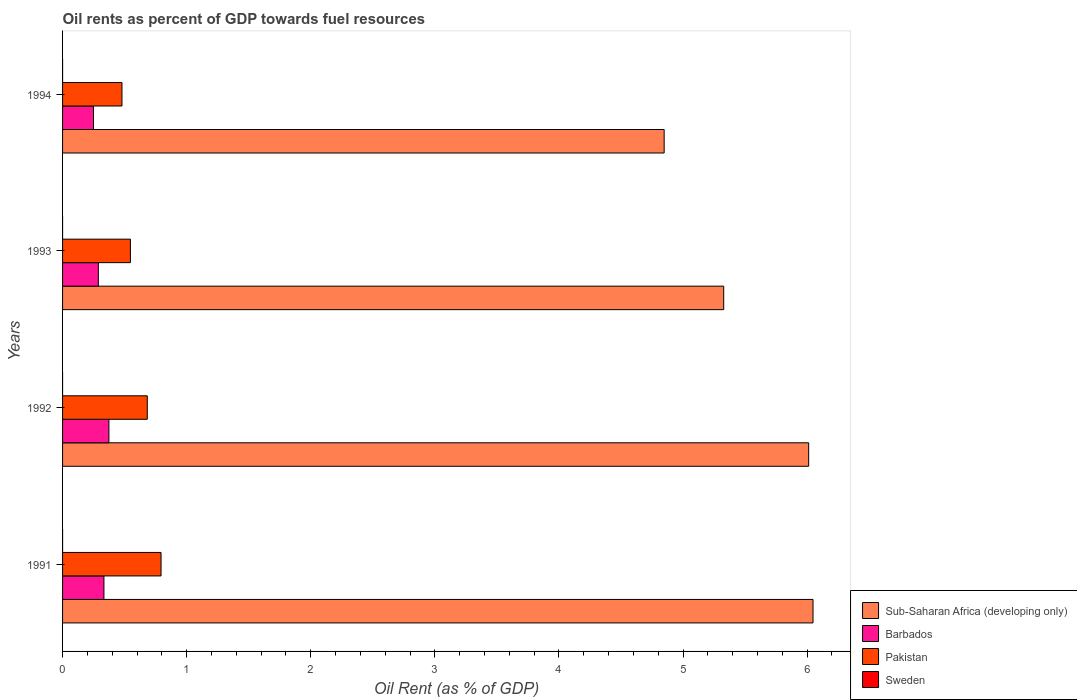How many groups of bars are there?
Give a very brief answer. 4. Are the number of bars per tick equal to the number of legend labels?
Keep it short and to the point. Yes. Are the number of bars on each tick of the Y-axis equal?
Ensure brevity in your answer.  Yes. What is the oil rent in Sweden in 1991?
Provide a short and direct response. 7.29985429798173e-5. Across all years, what is the maximum oil rent in Barbados?
Your answer should be very brief. 0.37. Across all years, what is the minimum oil rent in Pakistan?
Provide a short and direct response. 0.48. What is the total oil rent in Pakistan in the graph?
Your answer should be very brief. 2.5. What is the difference between the oil rent in Pakistan in 1992 and that in 1993?
Ensure brevity in your answer.  0.14. What is the difference between the oil rent in Sub-Saharan Africa (developing only) in 1993 and the oil rent in Sweden in 1992?
Give a very brief answer. 5.33. What is the average oil rent in Sweden per year?
Your answer should be very brief. 7.038638502322603e-5. In the year 1991, what is the difference between the oil rent in Barbados and oil rent in Sweden?
Your response must be concise. 0.33. What is the ratio of the oil rent in Pakistan in 1991 to that in 1992?
Keep it short and to the point. 1.16. Is the oil rent in Barbados in 1991 less than that in 1994?
Offer a terse response. No. What is the difference between the highest and the second highest oil rent in Sweden?
Your answer should be compact. 7.988289603777771e-5. What is the difference between the highest and the lowest oil rent in Sweden?
Your answer should be compact. 0. In how many years, is the oil rent in Pakistan greater than the average oil rent in Pakistan taken over all years?
Your answer should be compact. 2. Is the sum of the oil rent in Pakistan in 1993 and 1994 greater than the maximum oil rent in Sweden across all years?
Keep it short and to the point. Yes. Is it the case that in every year, the sum of the oil rent in Sub-Saharan Africa (developing only) and oil rent in Sweden is greater than the sum of oil rent in Barbados and oil rent in Pakistan?
Ensure brevity in your answer.  Yes. What does the 2nd bar from the top in 1993 represents?
Your answer should be very brief. Pakistan. What does the 2nd bar from the bottom in 1991 represents?
Offer a very short reply. Barbados. What is the difference between two consecutive major ticks on the X-axis?
Offer a terse response. 1. Are the values on the major ticks of X-axis written in scientific E-notation?
Give a very brief answer. No. Does the graph contain any zero values?
Your answer should be compact. No. Does the graph contain grids?
Make the answer very short. No. Where does the legend appear in the graph?
Your response must be concise. Bottom right. How many legend labels are there?
Give a very brief answer. 4. How are the legend labels stacked?
Ensure brevity in your answer.  Vertical. What is the title of the graph?
Your response must be concise. Oil rents as percent of GDP towards fuel resources. What is the label or title of the X-axis?
Offer a very short reply. Oil Rent (as % of GDP). What is the label or title of the Y-axis?
Keep it short and to the point. Years. What is the Oil Rent (as % of GDP) in Sub-Saharan Africa (developing only) in 1991?
Your answer should be compact. 6.05. What is the Oil Rent (as % of GDP) in Barbados in 1991?
Keep it short and to the point. 0.33. What is the Oil Rent (as % of GDP) in Pakistan in 1991?
Your response must be concise. 0.79. What is the Oil Rent (as % of GDP) in Sweden in 1991?
Ensure brevity in your answer.  7.29985429798173e-5. What is the Oil Rent (as % of GDP) in Sub-Saharan Africa (developing only) in 1992?
Your response must be concise. 6.01. What is the Oil Rent (as % of GDP) of Barbados in 1992?
Offer a very short reply. 0.37. What is the Oil Rent (as % of GDP) of Pakistan in 1992?
Offer a very short reply. 0.68. What is the Oil Rent (as % of GDP) of Sweden in 1992?
Your answer should be compact. 3.389702353146829e-5. What is the Oil Rent (as % of GDP) in Sub-Saharan Africa (developing only) in 1993?
Ensure brevity in your answer.  5.33. What is the Oil Rent (as % of GDP) in Barbados in 1993?
Keep it short and to the point. 0.29. What is the Oil Rent (as % of GDP) in Pakistan in 1993?
Keep it short and to the point. 0.55. What is the Oil Rent (as % of GDP) in Sweden in 1993?
Your answer should be very brief. 2.176853456402349e-5. What is the Oil Rent (as % of GDP) in Sub-Saharan Africa (developing only) in 1994?
Make the answer very short. 4.85. What is the Oil Rent (as % of GDP) in Barbados in 1994?
Provide a short and direct response. 0.25. What is the Oil Rent (as % of GDP) in Pakistan in 1994?
Keep it short and to the point. 0.48. What is the Oil Rent (as % of GDP) of Sweden in 1994?
Your response must be concise. 0. Across all years, what is the maximum Oil Rent (as % of GDP) in Sub-Saharan Africa (developing only)?
Offer a very short reply. 6.05. Across all years, what is the maximum Oil Rent (as % of GDP) in Barbados?
Your answer should be compact. 0.37. Across all years, what is the maximum Oil Rent (as % of GDP) in Pakistan?
Your answer should be compact. 0.79. Across all years, what is the maximum Oil Rent (as % of GDP) in Sweden?
Keep it short and to the point. 0. Across all years, what is the minimum Oil Rent (as % of GDP) in Sub-Saharan Africa (developing only)?
Your answer should be very brief. 4.85. Across all years, what is the minimum Oil Rent (as % of GDP) in Barbados?
Your answer should be compact. 0.25. Across all years, what is the minimum Oil Rent (as % of GDP) of Pakistan?
Ensure brevity in your answer.  0.48. Across all years, what is the minimum Oil Rent (as % of GDP) of Sweden?
Your answer should be very brief. 2.176853456402349e-5. What is the total Oil Rent (as % of GDP) of Sub-Saharan Africa (developing only) in the graph?
Provide a short and direct response. 22.24. What is the total Oil Rent (as % of GDP) of Barbados in the graph?
Ensure brevity in your answer.  1.24. What is the total Oil Rent (as % of GDP) of Pakistan in the graph?
Offer a terse response. 2.5. What is the difference between the Oil Rent (as % of GDP) of Sub-Saharan Africa (developing only) in 1991 and that in 1992?
Your response must be concise. 0.04. What is the difference between the Oil Rent (as % of GDP) of Barbados in 1991 and that in 1992?
Provide a succinct answer. -0.04. What is the difference between the Oil Rent (as % of GDP) in Pakistan in 1991 and that in 1992?
Give a very brief answer. 0.11. What is the difference between the Oil Rent (as % of GDP) of Sweden in 1991 and that in 1992?
Make the answer very short. 0. What is the difference between the Oil Rent (as % of GDP) of Sub-Saharan Africa (developing only) in 1991 and that in 1993?
Keep it short and to the point. 0.72. What is the difference between the Oil Rent (as % of GDP) of Barbados in 1991 and that in 1993?
Your response must be concise. 0.05. What is the difference between the Oil Rent (as % of GDP) of Pakistan in 1991 and that in 1993?
Make the answer very short. 0.25. What is the difference between the Oil Rent (as % of GDP) of Sub-Saharan Africa (developing only) in 1991 and that in 1994?
Your answer should be compact. 1.2. What is the difference between the Oil Rent (as % of GDP) of Barbados in 1991 and that in 1994?
Give a very brief answer. 0.08. What is the difference between the Oil Rent (as % of GDP) in Pakistan in 1991 and that in 1994?
Your answer should be compact. 0.31. What is the difference between the Oil Rent (as % of GDP) of Sweden in 1991 and that in 1994?
Provide a succinct answer. -0. What is the difference between the Oil Rent (as % of GDP) of Sub-Saharan Africa (developing only) in 1992 and that in 1993?
Provide a succinct answer. 0.68. What is the difference between the Oil Rent (as % of GDP) of Barbados in 1992 and that in 1993?
Ensure brevity in your answer.  0.09. What is the difference between the Oil Rent (as % of GDP) in Pakistan in 1992 and that in 1993?
Offer a terse response. 0.14. What is the difference between the Oil Rent (as % of GDP) in Sweden in 1992 and that in 1993?
Offer a very short reply. 0. What is the difference between the Oil Rent (as % of GDP) of Sub-Saharan Africa (developing only) in 1992 and that in 1994?
Give a very brief answer. 1.16. What is the difference between the Oil Rent (as % of GDP) of Barbados in 1992 and that in 1994?
Provide a short and direct response. 0.12. What is the difference between the Oil Rent (as % of GDP) of Pakistan in 1992 and that in 1994?
Your answer should be very brief. 0.2. What is the difference between the Oil Rent (as % of GDP) in Sweden in 1992 and that in 1994?
Provide a short and direct response. -0. What is the difference between the Oil Rent (as % of GDP) in Sub-Saharan Africa (developing only) in 1993 and that in 1994?
Your answer should be very brief. 0.48. What is the difference between the Oil Rent (as % of GDP) in Barbados in 1993 and that in 1994?
Provide a succinct answer. 0.04. What is the difference between the Oil Rent (as % of GDP) in Pakistan in 1993 and that in 1994?
Offer a very short reply. 0.07. What is the difference between the Oil Rent (as % of GDP) of Sweden in 1993 and that in 1994?
Make the answer very short. -0. What is the difference between the Oil Rent (as % of GDP) of Sub-Saharan Africa (developing only) in 1991 and the Oil Rent (as % of GDP) of Barbados in 1992?
Offer a very short reply. 5.67. What is the difference between the Oil Rent (as % of GDP) of Sub-Saharan Africa (developing only) in 1991 and the Oil Rent (as % of GDP) of Pakistan in 1992?
Make the answer very short. 5.37. What is the difference between the Oil Rent (as % of GDP) of Sub-Saharan Africa (developing only) in 1991 and the Oil Rent (as % of GDP) of Sweden in 1992?
Provide a succinct answer. 6.05. What is the difference between the Oil Rent (as % of GDP) of Barbados in 1991 and the Oil Rent (as % of GDP) of Pakistan in 1992?
Offer a terse response. -0.35. What is the difference between the Oil Rent (as % of GDP) of Barbados in 1991 and the Oil Rent (as % of GDP) of Sweden in 1992?
Provide a succinct answer. 0.33. What is the difference between the Oil Rent (as % of GDP) in Pakistan in 1991 and the Oil Rent (as % of GDP) in Sweden in 1992?
Your answer should be very brief. 0.79. What is the difference between the Oil Rent (as % of GDP) in Sub-Saharan Africa (developing only) in 1991 and the Oil Rent (as % of GDP) in Barbados in 1993?
Give a very brief answer. 5.76. What is the difference between the Oil Rent (as % of GDP) in Sub-Saharan Africa (developing only) in 1991 and the Oil Rent (as % of GDP) in Pakistan in 1993?
Give a very brief answer. 5.5. What is the difference between the Oil Rent (as % of GDP) of Sub-Saharan Africa (developing only) in 1991 and the Oil Rent (as % of GDP) of Sweden in 1993?
Provide a succinct answer. 6.05. What is the difference between the Oil Rent (as % of GDP) of Barbados in 1991 and the Oil Rent (as % of GDP) of Pakistan in 1993?
Your response must be concise. -0.21. What is the difference between the Oil Rent (as % of GDP) of Barbados in 1991 and the Oil Rent (as % of GDP) of Sweden in 1993?
Offer a terse response. 0.33. What is the difference between the Oil Rent (as % of GDP) in Pakistan in 1991 and the Oil Rent (as % of GDP) in Sweden in 1993?
Make the answer very short. 0.79. What is the difference between the Oil Rent (as % of GDP) in Sub-Saharan Africa (developing only) in 1991 and the Oil Rent (as % of GDP) in Barbados in 1994?
Give a very brief answer. 5.8. What is the difference between the Oil Rent (as % of GDP) of Sub-Saharan Africa (developing only) in 1991 and the Oil Rent (as % of GDP) of Pakistan in 1994?
Provide a short and direct response. 5.57. What is the difference between the Oil Rent (as % of GDP) of Sub-Saharan Africa (developing only) in 1991 and the Oil Rent (as % of GDP) of Sweden in 1994?
Your response must be concise. 6.05. What is the difference between the Oil Rent (as % of GDP) of Barbados in 1991 and the Oil Rent (as % of GDP) of Pakistan in 1994?
Keep it short and to the point. -0.15. What is the difference between the Oil Rent (as % of GDP) of Barbados in 1991 and the Oil Rent (as % of GDP) of Sweden in 1994?
Provide a short and direct response. 0.33. What is the difference between the Oil Rent (as % of GDP) in Pakistan in 1991 and the Oil Rent (as % of GDP) in Sweden in 1994?
Make the answer very short. 0.79. What is the difference between the Oil Rent (as % of GDP) of Sub-Saharan Africa (developing only) in 1992 and the Oil Rent (as % of GDP) of Barbados in 1993?
Offer a very short reply. 5.72. What is the difference between the Oil Rent (as % of GDP) of Sub-Saharan Africa (developing only) in 1992 and the Oil Rent (as % of GDP) of Pakistan in 1993?
Keep it short and to the point. 5.47. What is the difference between the Oil Rent (as % of GDP) in Sub-Saharan Africa (developing only) in 1992 and the Oil Rent (as % of GDP) in Sweden in 1993?
Provide a short and direct response. 6.01. What is the difference between the Oil Rent (as % of GDP) of Barbados in 1992 and the Oil Rent (as % of GDP) of Pakistan in 1993?
Keep it short and to the point. -0.17. What is the difference between the Oil Rent (as % of GDP) in Barbados in 1992 and the Oil Rent (as % of GDP) in Sweden in 1993?
Keep it short and to the point. 0.37. What is the difference between the Oil Rent (as % of GDP) of Pakistan in 1992 and the Oil Rent (as % of GDP) of Sweden in 1993?
Your answer should be compact. 0.68. What is the difference between the Oil Rent (as % of GDP) in Sub-Saharan Africa (developing only) in 1992 and the Oil Rent (as % of GDP) in Barbados in 1994?
Provide a short and direct response. 5.76. What is the difference between the Oil Rent (as % of GDP) in Sub-Saharan Africa (developing only) in 1992 and the Oil Rent (as % of GDP) in Pakistan in 1994?
Make the answer very short. 5.53. What is the difference between the Oil Rent (as % of GDP) in Sub-Saharan Africa (developing only) in 1992 and the Oil Rent (as % of GDP) in Sweden in 1994?
Provide a short and direct response. 6.01. What is the difference between the Oil Rent (as % of GDP) of Barbados in 1992 and the Oil Rent (as % of GDP) of Pakistan in 1994?
Your response must be concise. -0.11. What is the difference between the Oil Rent (as % of GDP) in Barbados in 1992 and the Oil Rent (as % of GDP) in Sweden in 1994?
Make the answer very short. 0.37. What is the difference between the Oil Rent (as % of GDP) in Pakistan in 1992 and the Oil Rent (as % of GDP) in Sweden in 1994?
Provide a short and direct response. 0.68. What is the difference between the Oil Rent (as % of GDP) of Sub-Saharan Africa (developing only) in 1993 and the Oil Rent (as % of GDP) of Barbados in 1994?
Ensure brevity in your answer.  5.08. What is the difference between the Oil Rent (as % of GDP) of Sub-Saharan Africa (developing only) in 1993 and the Oil Rent (as % of GDP) of Pakistan in 1994?
Your answer should be compact. 4.85. What is the difference between the Oil Rent (as % of GDP) of Sub-Saharan Africa (developing only) in 1993 and the Oil Rent (as % of GDP) of Sweden in 1994?
Your answer should be compact. 5.33. What is the difference between the Oil Rent (as % of GDP) of Barbados in 1993 and the Oil Rent (as % of GDP) of Pakistan in 1994?
Give a very brief answer. -0.19. What is the difference between the Oil Rent (as % of GDP) of Barbados in 1993 and the Oil Rent (as % of GDP) of Sweden in 1994?
Your answer should be very brief. 0.29. What is the difference between the Oil Rent (as % of GDP) of Pakistan in 1993 and the Oil Rent (as % of GDP) of Sweden in 1994?
Your response must be concise. 0.55. What is the average Oil Rent (as % of GDP) in Sub-Saharan Africa (developing only) per year?
Provide a short and direct response. 5.56. What is the average Oil Rent (as % of GDP) of Barbados per year?
Offer a terse response. 0.31. What is the average Oil Rent (as % of GDP) in Pakistan per year?
Make the answer very short. 0.63. In the year 1991, what is the difference between the Oil Rent (as % of GDP) of Sub-Saharan Africa (developing only) and Oil Rent (as % of GDP) of Barbados?
Your answer should be very brief. 5.71. In the year 1991, what is the difference between the Oil Rent (as % of GDP) of Sub-Saharan Africa (developing only) and Oil Rent (as % of GDP) of Pakistan?
Make the answer very short. 5.25. In the year 1991, what is the difference between the Oil Rent (as % of GDP) of Sub-Saharan Africa (developing only) and Oil Rent (as % of GDP) of Sweden?
Make the answer very short. 6.05. In the year 1991, what is the difference between the Oil Rent (as % of GDP) of Barbados and Oil Rent (as % of GDP) of Pakistan?
Provide a succinct answer. -0.46. In the year 1991, what is the difference between the Oil Rent (as % of GDP) of Barbados and Oil Rent (as % of GDP) of Sweden?
Your answer should be compact. 0.33. In the year 1991, what is the difference between the Oil Rent (as % of GDP) of Pakistan and Oil Rent (as % of GDP) of Sweden?
Keep it short and to the point. 0.79. In the year 1992, what is the difference between the Oil Rent (as % of GDP) of Sub-Saharan Africa (developing only) and Oil Rent (as % of GDP) of Barbados?
Your response must be concise. 5.64. In the year 1992, what is the difference between the Oil Rent (as % of GDP) of Sub-Saharan Africa (developing only) and Oil Rent (as % of GDP) of Pakistan?
Offer a very short reply. 5.33. In the year 1992, what is the difference between the Oil Rent (as % of GDP) in Sub-Saharan Africa (developing only) and Oil Rent (as % of GDP) in Sweden?
Provide a short and direct response. 6.01. In the year 1992, what is the difference between the Oil Rent (as % of GDP) of Barbados and Oil Rent (as % of GDP) of Pakistan?
Provide a succinct answer. -0.31. In the year 1992, what is the difference between the Oil Rent (as % of GDP) of Barbados and Oil Rent (as % of GDP) of Sweden?
Your answer should be compact. 0.37. In the year 1992, what is the difference between the Oil Rent (as % of GDP) in Pakistan and Oil Rent (as % of GDP) in Sweden?
Provide a short and direct response. 0.68. In the year 1993, what is the difference between the Oil Rent (as % of GDP) of Sub-Saharan Africa (developing only) and Oil Rent (as % of GDP) of Barbados?
Offer a terse response. 5.04. In the year 1993, what is the difference between the Oil Rent (as % of GDP) of Sub-Saharan Africa (developing only) and Oil Rent (as % of GDP) of Pakistan?
Make the answer very short. 4.78. In the year 1993, what is the difference between the Oil Rent (as % of GDP) in Sub-Saharan Africa (developing only) and Oil Rent (as % of GDP) in Sweden?
Your answer should be very brief. 5.33. In the year 1993, what is the difference between the Oil Rent (as % of GDP) of Barbados and Oil Rent (as % of GDP) of Pakistan?
Your response must be concise. -0.26. In the year 1993, what is the difference between the Oil Rent (as % of GDP) in Barbados and Oil Rent (as % of GDP) in Sweden?
Provide a short and direct response. 0.29. In the year 1993, what is the difference between the Oil Rent (as % of GDP) in Pakistan and Oil Rent (as % of GDP) in Sweden?
Your answer should be compact. 0.55. In the year 1994, what is the difference between the Oil Rent (as % of GDP) in Sub-Saharan Africa (developing only) and Oil Rent (as % of GDP) in Barbados?
Offer a very short reply. 4.6. In the year 1994, what is the difference between the Oil Rent (as % of GDP) in Sub-Saharan Africa (developing only) and Oil Rent (as % of GDP) in Pakistan?
Offer a terse response. 4.37. In the year 1994, what is the difference between the Oil Rent (as % of GDP) in Sub-Saharan Africa (developing only) and Oil Rent (as % of GDP) in Sweden?
Provide a short and direct response. 4.85. In the year 1994, what is the difference between the Oil Rent (as % of GDP) of Barbados and Oil Rent (as % of GDP) of Pakistan?
Offer a very short reply. -0.23. In the year 1994, what is the difference between the Oil Rent (as % of GDP) in Barbados and Oil Rent (as % of GDP) in Sweden?
Your answer should be compact. 0.25. In the year 1994, what is the difference between the Oil Rent (as % of GDP) of Pakistan and Oil Rent (as % of GDP) of Sweden?
Your response must be concise. 0.48. What is the ratio of the Oil Rent (as % of GDP) of Barbados in 1991 to that in 1992?
Make the answer very short. 0.89. What is the ratio of the Oil Rent (as % of GDP) of Pakistan in 1991 to that in 1992?
Provide a succinct answer. 1.16. What is the ratio of the Oil Rent (as % of GDP) of Sweden in 1991 to that in 1992?
Give a very brief answer. 2.15. What is the ratio of the Oil Rent (as % of GDP) of Sub-Saharan Africa (developing only) in 1991 to that in 1993?
Your answer should be compact. 1.14. What is the ratio of the Oil Rent (as % of GDP) of Barbados in 1991 to that in 1993?
Ensure brevity in your answer.  1.16. What is the ratio of the Oil Rent (as % of GDP) of Pakistan in 1991 to that in 1993?
Offer a very short reply. 1.45. What is the ratio of the Oil Rent (as % of GDP) of Sweden in 1991 to that in 1993?
Your answer should be compact. 3.35. What is the ratio of the Oil Rent (as % of GDP) in Sub-Saharan Africa (developing only) in 1991 to that in 1994?
Your answer should be compact. 1.25. What is the ratio of the Oil Rent (as % of GDP) of Barbados in 1991 to that in 1994?
Provide a short and direct response. 1.34. What is the ratio of the Oil Rent (as % of GDP) of Pakistan in 1991 to that in 1994?
Provide a short and direct response. 1.66. What is the ratio of the Oil Rent (as % of GDP) in Sweden in 1991 to that in 1994?
Offer a terse response. 0.48. What is the ratio of the Oil Rent (as % of GDP) in Sub-Saharan Africa (developing only) in 1992 to that in 1993?
Offer a very short reply. 1.13. What is the ratio of the Oil Rent (as % of GDP) of Barbados in 1992 to that in 1993?
Make the answer very short. 1.3. What is the ratio of the Oil Rent (as % of GDP) of Pakistan in 1992 to that in 1993?
Ensure brevity in your answer.  1.25. What is the ratio of the Oil Rent (as % of GDP) in Sweden in 1992 to that in 1993?
Your answer should be compact. 1.56. What is the ratio of the Oil Rent (as % of GDP) of Sub-Saharan Africa (developing only) in 1992 to that in 1994?
Your response must be concise. 1.24. What is the ratio of the Oil Rent (as % of GDP) in Barbados in 1992 to that in 1994?
Give a very brief answer. 1.5. What is the ratio of the Oil Rent (as % of GDP) of Pakistan in 1992 to that in 1994?
Make the answer very short. 1.43. What is the ratio of the Oil Rent (as % of GDP) in Sweden in 1992 to that in 1994?
Offer a terse response. 0.22. What is the ratio of the Oil Rent (as % of GDP) of Sub-Saharan Africa (developing only) in 1993 to that in 1994?
Ensure brevity in your answer.  1.1. What is the ratio of the Oil Rent (as % of GDP) of Barbados in 1993 to that in 1994?
Ensure brevity in your answer.  1.16. What is the ratio of the Oil Rent (as % of GDP) of Pakistan in 1993 to that in 1994?
Your answer should be very brief. 1.14. What is the ratio of the Oil Rent (as % of GDP) of Sweden in 1993 to that in 1994?
Make the answer very short. 0.14. What is the difference between the highest and the second highest Oil Rent (as % of GDP) of Sub-Saharan Africa (developing only)?
Offer a terse response. 0.04. What is the difference between the highest and the second highest Oil Rent (as % of GDP) in Barbados?
Ensure brevity in your answer.  0.04. What is the difference between the highest and the second highest Oil Rent (as % of GDP) in Pakistan?
Offer a very short reply. 0.11. What is the difference between the highest and the lowest Oil Rent (as % of GDP) of Sub-Saharan Africa (developing only)?
Your answer should be compact. 1.2. What is the difference between the highest and the lowest Oil Rent (as % of GDP) of Barbados?
Provide a succinct answer. 0.12. What is the difference between the highest and the lowest Oil Rent (as % of GDP) of Pakistan?
Keep it short and to the point. 0.31. 